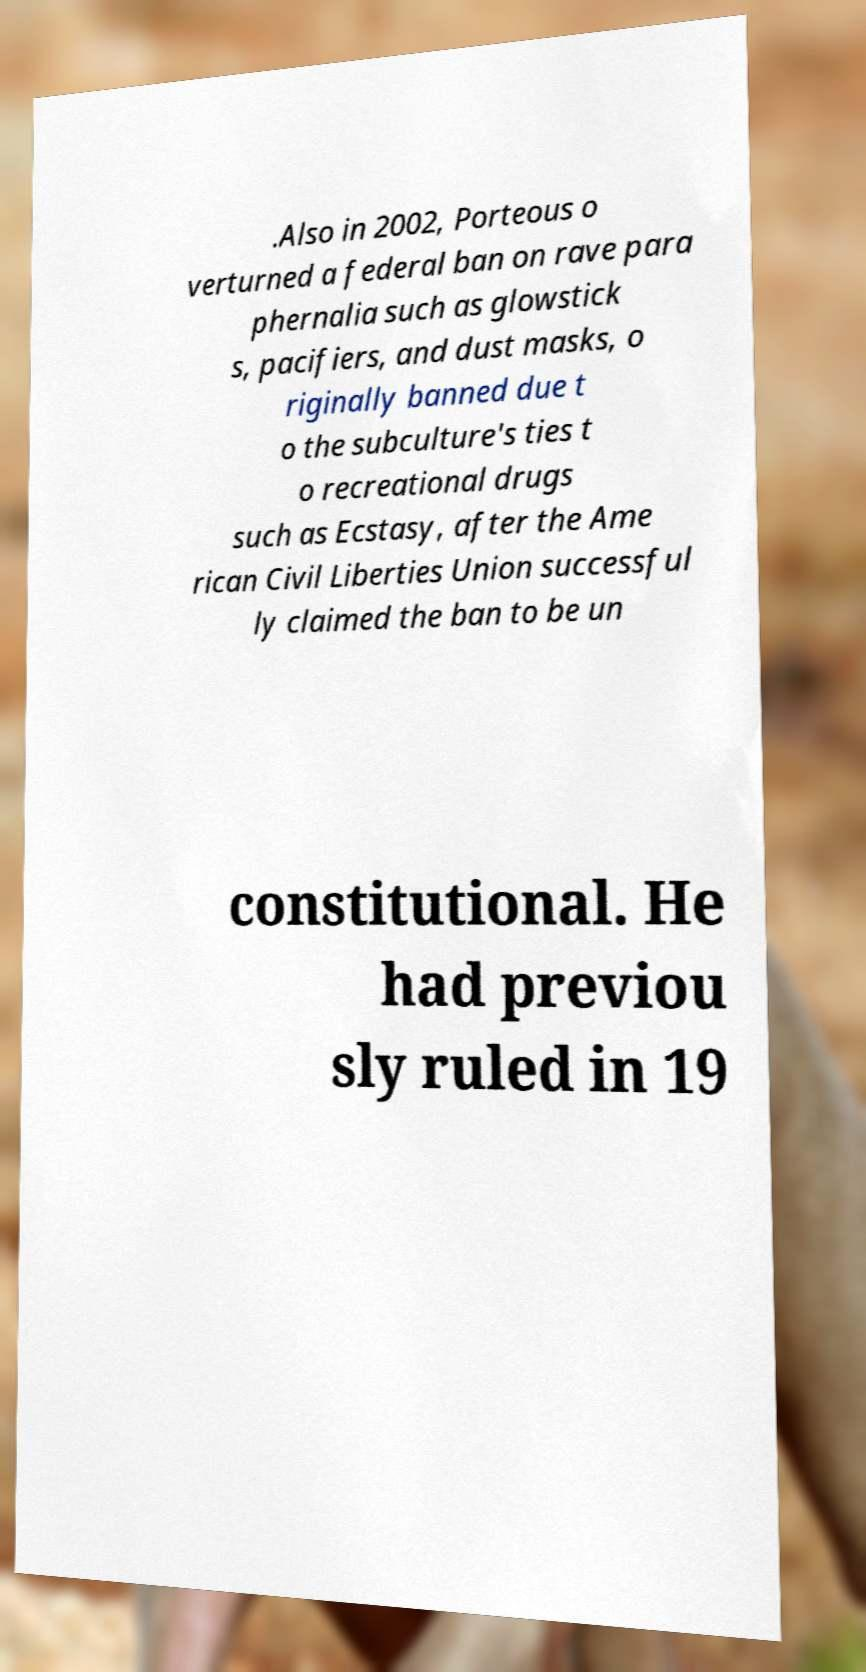Could you extract and type out the text from this image? .Also in 2002, Porteous o verturned a federal ban on rave para phernalia such as glowstick s, pacifiers, and dust masks, o riginally banned due t o the subculture's ties t o recreational drugs such as Ecstasy, after the Ame rican Civil Liberties Union successful ly claimed the ban to be un constitutional. He had previou sly ruled in 19 